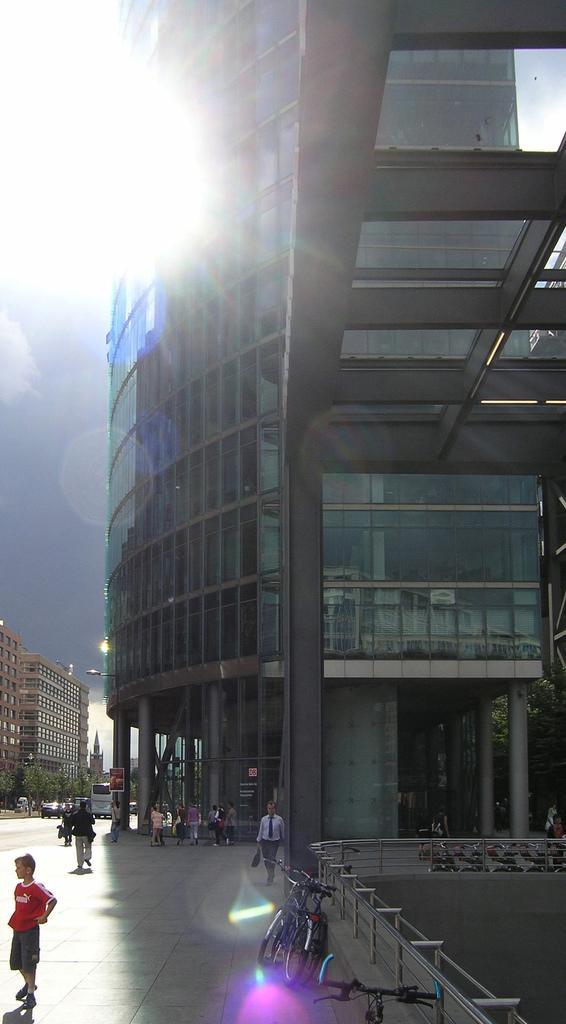Can you describe this image briefly? In this picture we can see some people are walking and some people are standing on the path. On the right side of the people there are bicycles and iron grills. Behind the people there are buildings and the sky. 